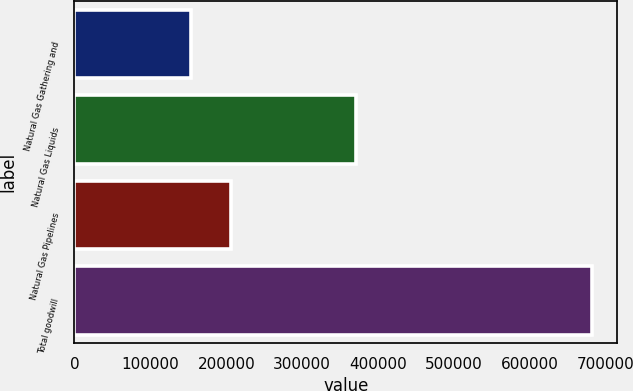Convert chart to OTSL. <chart><loc_0><loc_0><loc_500><loc_500><bar_chart><fcel>Natural Gas Gathering and<fcel>Natural Gas Liquids<fcel>Natural Gas Pipelines<fcel>Total goodwill<nl><fcel>153404<fcel>371217<fcel>206174<fcel>681100<nl></chart> 